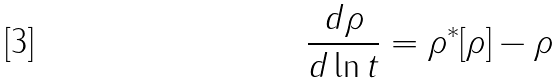<formula> <loc_0><loc_0><loc_500><loc_500>\frac { d \rho } { d \ln t } = \rho ^ { * } [ \rho ] - \rho</formula> 